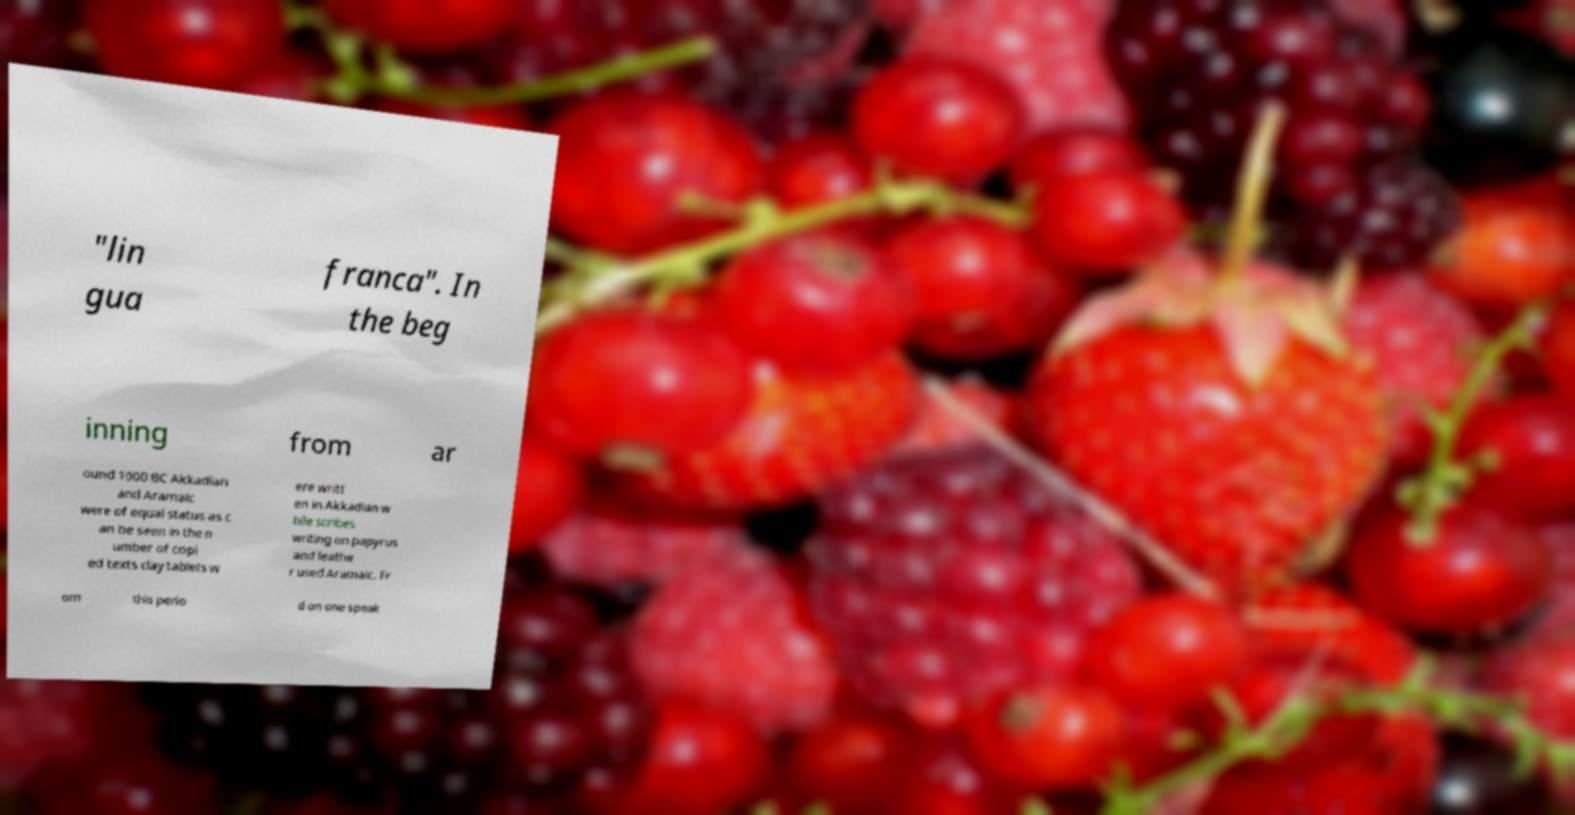Please identify and transcribe the text found in this image. "lin gua franca". In the beg inning from ar ound 1000 BC Akkadian and Aramaic were of equal status as c an be seen in the n umber of copi ed texts clay tablets w ere writt en in Akkadian w hile scribes writing on papyrus and leathe r used Aramaic. Fr om this perio d on one speak 